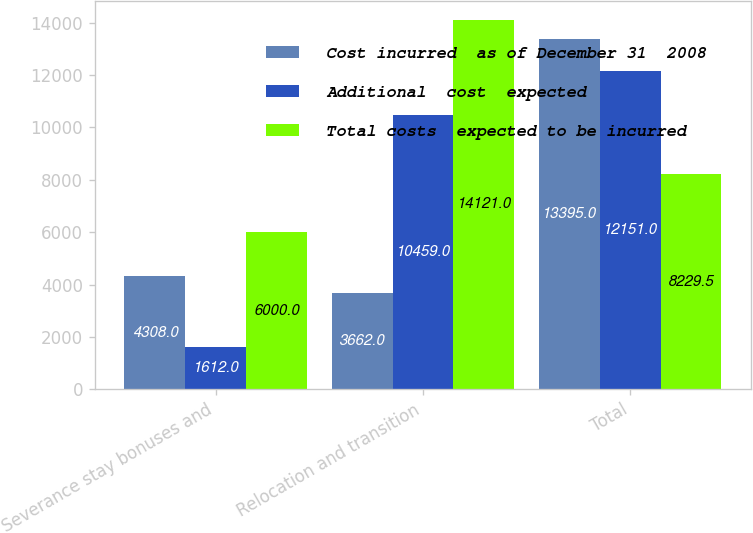Convert chart to OTSL. <chart><loc_0><loc_0><loc_500><loc_500><stacked_bar_chart><ecel><fcel>Severance stay bonuses and<fcel>Relocation and transition<fcel>Total<nl><fcel>Cost incurred  as of December 31  2008<fcel>4308<fcel>3662<fcel>13395<nl><fcel>Additional  cost  expected<fcel>1612<fcel>10459<fcel>12151<nl><fcel>Total costs  expected to be incurred<fcel>6000<fcel>14121<fcel>8229.5<nl></chart> 